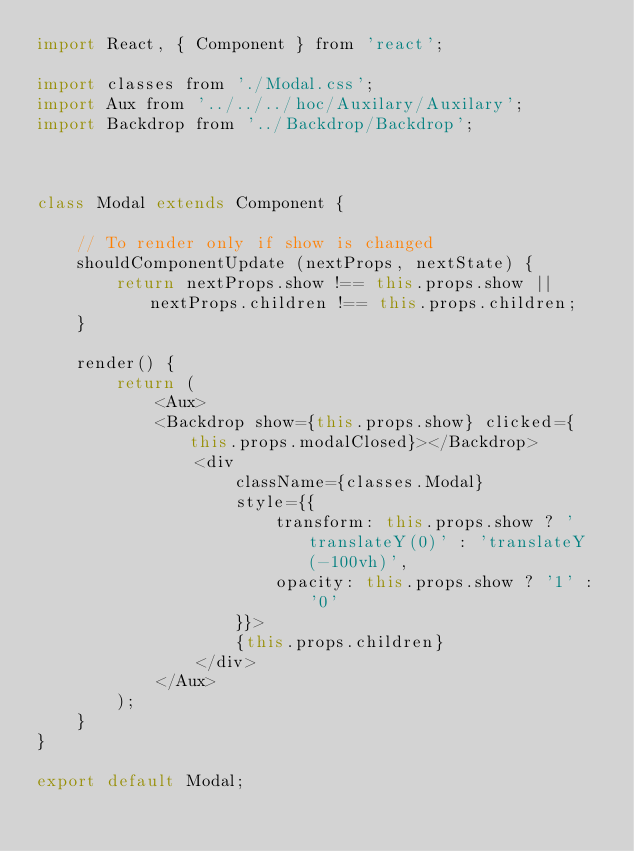<code> <loc_0><loc_0><loc_500><loc_500><_JavaScript_>import React, { Component } from 'react';

import classes from './Modal.css';
import Aux from '../../../hoc/Auxilary/Auxilary';
import Backdrop from '../Backdrop/Backdrop';



class Modal extends Component {

    // To render only if show is changed
    shouldComponentUpdate (nextProps, nextState) {
        return nextProps.show !== this.props.show || nextProps.children !== this.props.children;
    }

    render() {
        return (
            <Aux>
            <Backdrop show={this.props.show} clicked={this.props.modalClosed}></Backdrop>
                <div 
                    className={classes.Modal}
                    style={{
                        transform: this.props.show ? 'translateY(0)' : 'translateY(-100vh)',
                        opacity: this.props.show ? '1' : '0' 
                    }}>
                    {this.props.children}
                </div>
            </Aux>
        );
    }
}

export default Modal;</code> 